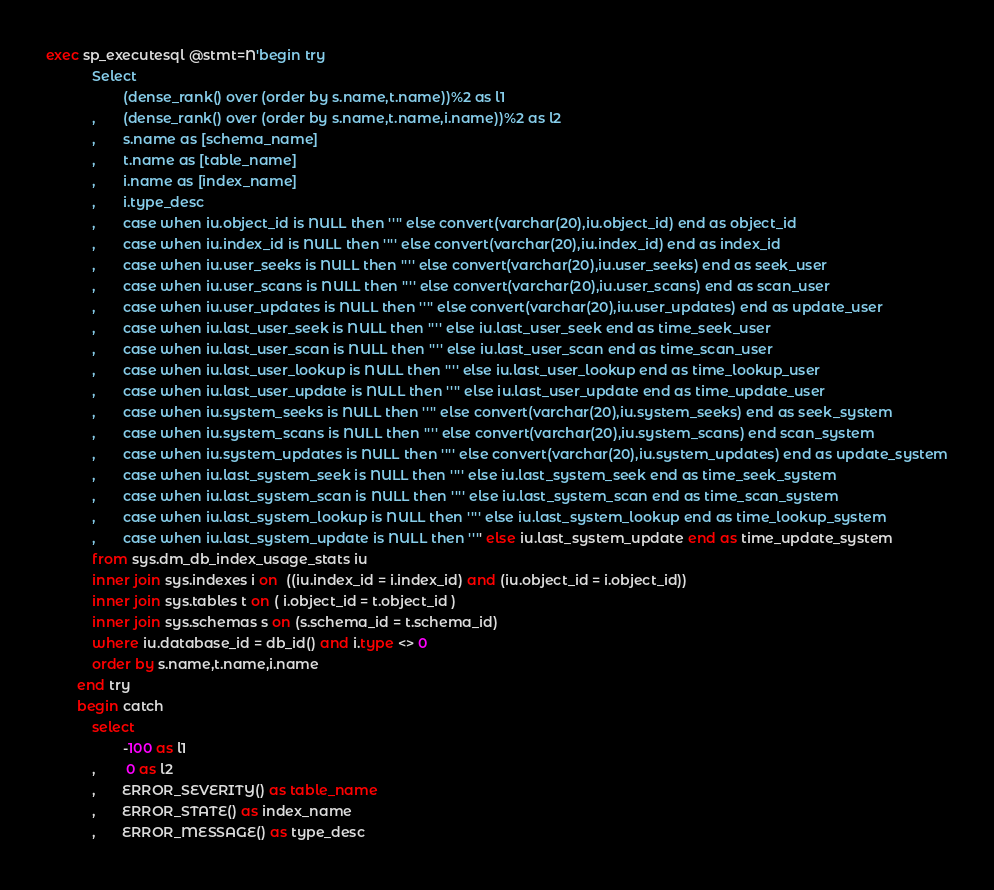<code> <loc_0><loc_0><loc_500><loc_500><_SQL_>exec sp_executesql @stmt=N'begin try  
			Select
					(dense_rank() over (order by s.name,t.name))%2 as l1
			,       (dense_rank() over (order by s.name,t.name,i.name))%2 as l2
			,		s.name as [schema_name]
			,       t.name as [table_name]
			,       i.name as [index_name]
			,       i.type_desc
			,       case when iu.object_id is NULL then '''' else convert(varchar(20),iu.object_id) end as object_id
			,       case when iu.index_id is NULL then '''' else convert(varchar(20),iu.index_id) end as index_id
			,       case when iu.user_seeks is NULL then '''' else convert(varchar(20),iu.user_seeks) end as seek_user
			,       case when iu.user_scans is NULL then '''' else convert(varchar(20),iu.user_scans) end as scan_user
			,       case when iu.user_updates is NULL then '''' else convert(varchar(20),iu.user_updates) end as update_user
			,       case when iu.last_user_seek is NULL then '''' else iu.last_user_seek end as time_seek_user
			,       case when iu.last_user_scan is NULL then '''' else iu.last_user_scan end as time_scan_user
			,       case when iu.last_user_lookup is NULL then '''' else iu.last_user_lookup end as time_lookup_user
			,       case when iu.last_user_update is NULL then '''' else iu.last_user_update end as time_update_user
			,       case when iu.system_seeks is NULL then '''' else convert(varchar(20),iu.system_seeks) end as seek_system
			,       case when iu.system_scans is NULL then '''' else convert(varchar(20),iu.system_scans) end scan_system
			,       case when iu.system_updates is NULL then '''' else convert(varchar(20),iu.system_updates) end as update_system
			,       case when iu.last_system_seek is NULL then '''' else iu.last_system_seek end as time_seek_system
			,       case when iu.last_system_scan is NULL then '''' else iu.last_system_scan end as time_scan_system
			,       case when iu.last_system_lookup is NULL then '''' else iu.last_system_lookup end as time_lookup_system
			,       case when iu.last_system_update is NULL then '''' else iu.last_system_update end as time_update_system
			from sys.dm_db_index_usage_stats iu
			inner join sys.indexes i on  ((iu.index_id = i.index_id) and (iu.object_id = i.object_id))
			inner join sys.tables t on ( i.object_id = t.object_id )
			inner join sys.schemas s on (s.schema_id = t.schema_id)
			where iu.database_id = db_id() and i.type <> 0
			order by s.name,t.name,i.name
		end try
		begin catch
			select
					-100 as l1
			,		0 as l2
			,       ERROR_SEVERITY() as table_name
			,       ERROR_STATE() as index_name
			,       ERROR_MESSAGE() as type_desc</code> 